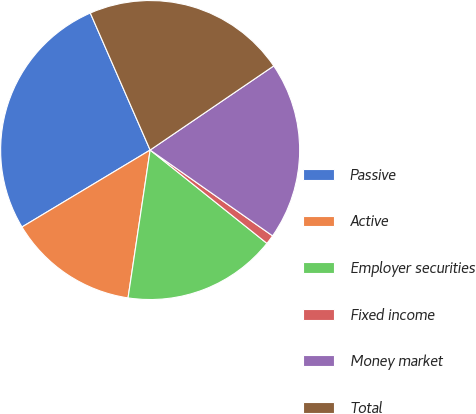Convert chart to OTSL. <chart><loc_0><loc_0><loc_500><loc_500><pie_chart><fcel>Passive<fcel>Active<fcel>Employer securities<fcel>Fixed income<fcel>Money market<fcel>Total<nl><fcel>27.05%<fcel>14.03%<fcel>16.63%<fcel>1.0%<fcel>19.24%<fcel>22.04%<nl></chart> 